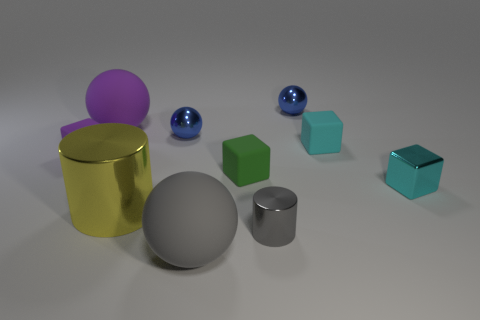Subtract 1 blocks. How many blocks are left? 3 Subtract all spheres. How many objects are left? 6 Subtract 1 green blocks. How many objects are left? 9 Subtract all big brown metallic spheres. Subtract all small blocks. How many objects are left? 6 Add 7 gray cylinders. How many gray cylinders are left? 8 Add 3 tiny purple matte cylinders. How many tiny purple matte cylinders exist? 3 